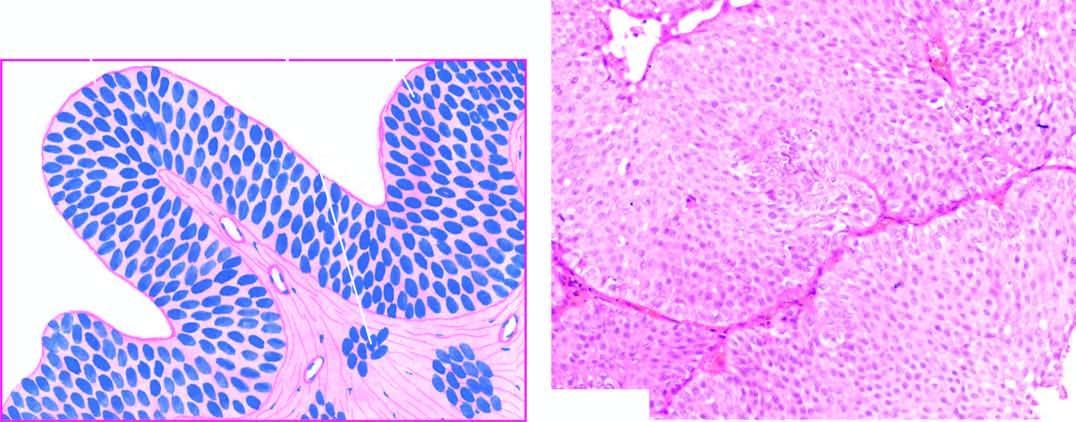re the cells still recognisable as of transitional origin and show features of anaplasia?
Answer the question using a single word or phrase. Yes 